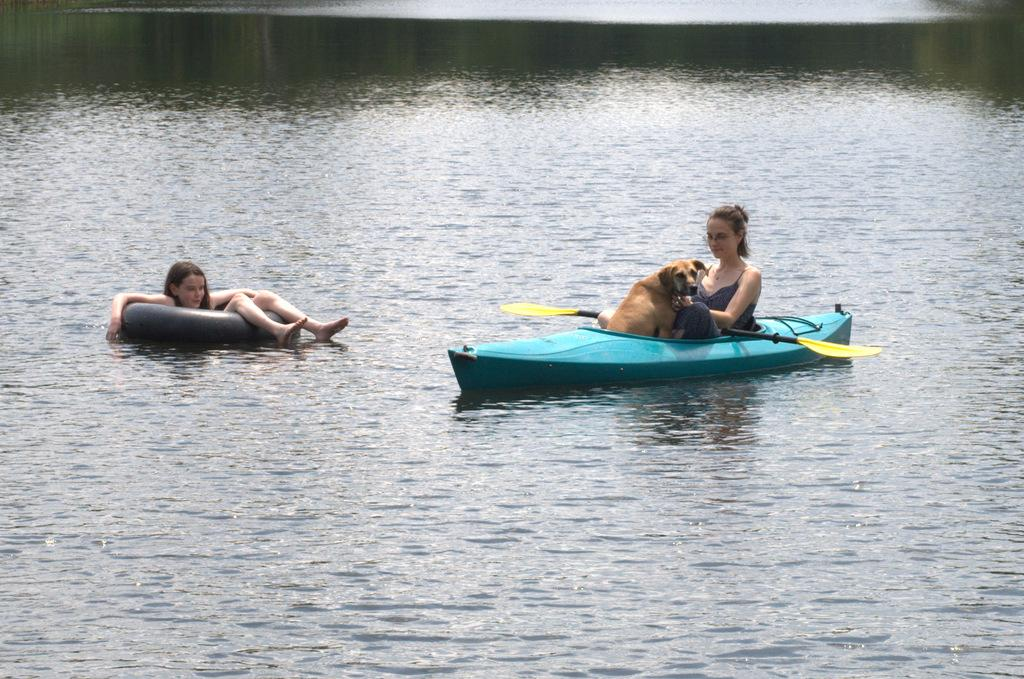What is the main element in the image? There is water in the image. What is floating on the water? There is a boat in the water. Who is in the boat? There is a lady and a dog in the boat. Where is the girl in the image? The girl is sitting on a swimming ring on the left side of the image. What type of butter is being used to grease the system in the image? There is no butter or system present in the image; it features water, a boat, a lady, a dog, and a girl on a swimming ring. 